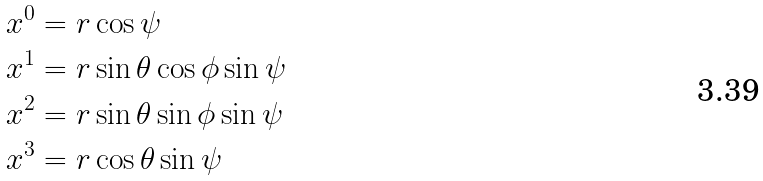<formula> <loc_0><loc_0><loc_500><loc_500>& x ^ { 0 } = r \cos \psi \\ & x ^ { 1 } = r \sin \theta \cos \phi \sin \psi \\ & x ^ { 2 } = r \sin \theta \sin \phi \sin \psi \\ & x ^ { 3 } = r \cos \theta \sin \psi</formula> 